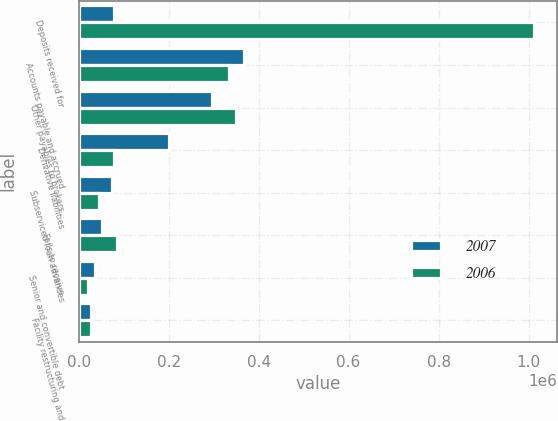Convert chart. <chart><loc_0><loc_0><loc_500><loc_500><stacked_bar_chart><ecel><fcel>Deposits received for<fcel>Accounts payable and accrued<fcel>Other payables to brokers<fcel>Derivative liabilities<fcel>Subserviced loan advances<fcel>Fails to receive<fcel>Senior and convertible debt<fcel>Facility restructuring and<nl><fcel>2007<fcel>78710<fcel>366891<fcel>295600<fcel>200293<fcel>73212<fcel>51177<fcel>35581<fcel>26651<nl><fcel>2006<fcel>1.01283e+06<fcel>335117<fcel>350221<fcel>78710<fcel>44780<fcel>84864<fcel>20125<fcel>26892<nl></chart> 